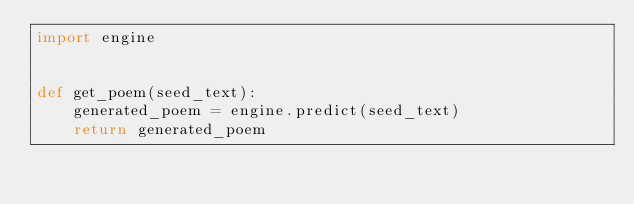Convert code to text. <code><loc_0><loc_0><loc_500><loc_500><_Python_>import engine


def get_poem(seed_text):
    generated_poem = engine.predict(seed_text)
    return generated_poem
</code> 